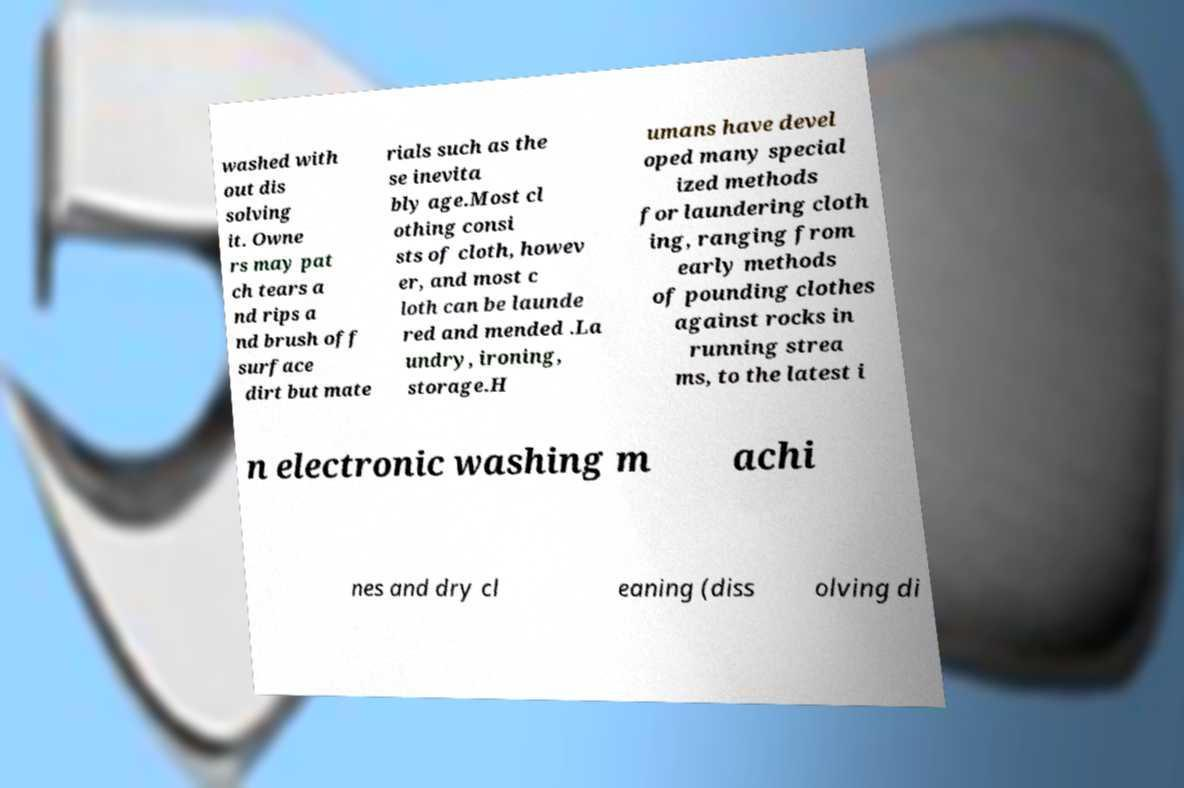I need the written content from this picture converted into text. Can you do that? washed with out dis solving it. Owne rs may pat ch tears a nd rips a nd brush off surface dirt but mate rials such as the se inevita bly age.Most cl othing consi sts of cloth, howev er, and most c loth can be launde red and mended .La undry, ironing, storage.H umans have devel oped many special ized methods for laundering cloth ing, ranging from early methods of pounding clothes against rocks in running strea ms, to the latest i n electronic washing m achi nes and dry cl eaning (diss olving di 